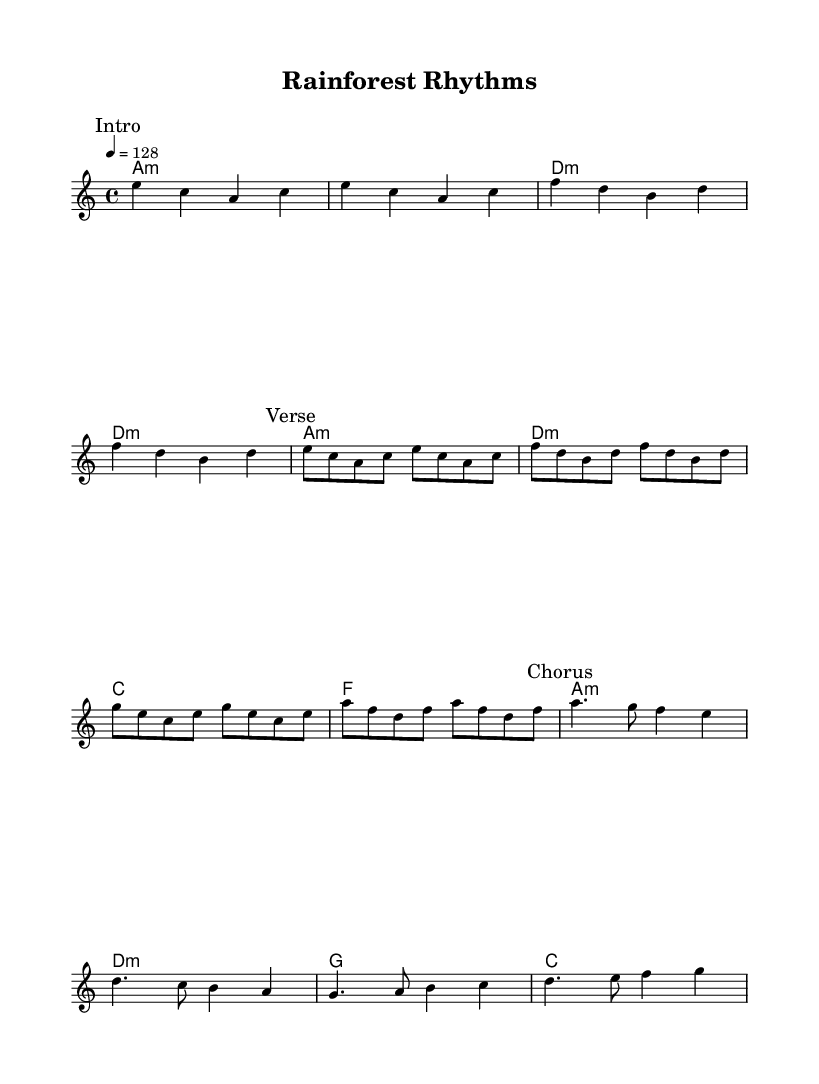What is the key signature of this music? The key signature indicated in the score is A minor, which has no sharps or flats. This can be identified by looking at the key signature at the beginning of the staff.
Answer: A minor What is the time signature of this music? The time signature shown in the score is 4/4, meaning there are four beats in each measure and the quarter note gets one beat. This is stated at the beginning of the score.
Answer: 4/4 What is the tempo of this music? The tempo marking in the score indicates a speed of 128 beats per minute, which is mentioned at the start as "4 = 128".
Answer: 128 What section follows the "Intro"? The next section after the "Intro" is labeled as "Verse" in the score. The markings make it easy to track the structure of the piece.
Answer: Verse How many measures are in the "Chorus" section? The "Chorus" section consists of four measures in total, as indicated by the notation of the notes in that labeled segment.
Answer: 4 How many different chords are used in the "Verse"? The "Verse" utilizes three different chords: A minor, D minor, and F major, which can be identified by examining the chord changes indicated in the harmonies.
Answer: 3 What is the last note played in the "Chorus"? The last note in the "Chorus" section is G, which can be found at the end of the last measure in that section.
Answer: G 